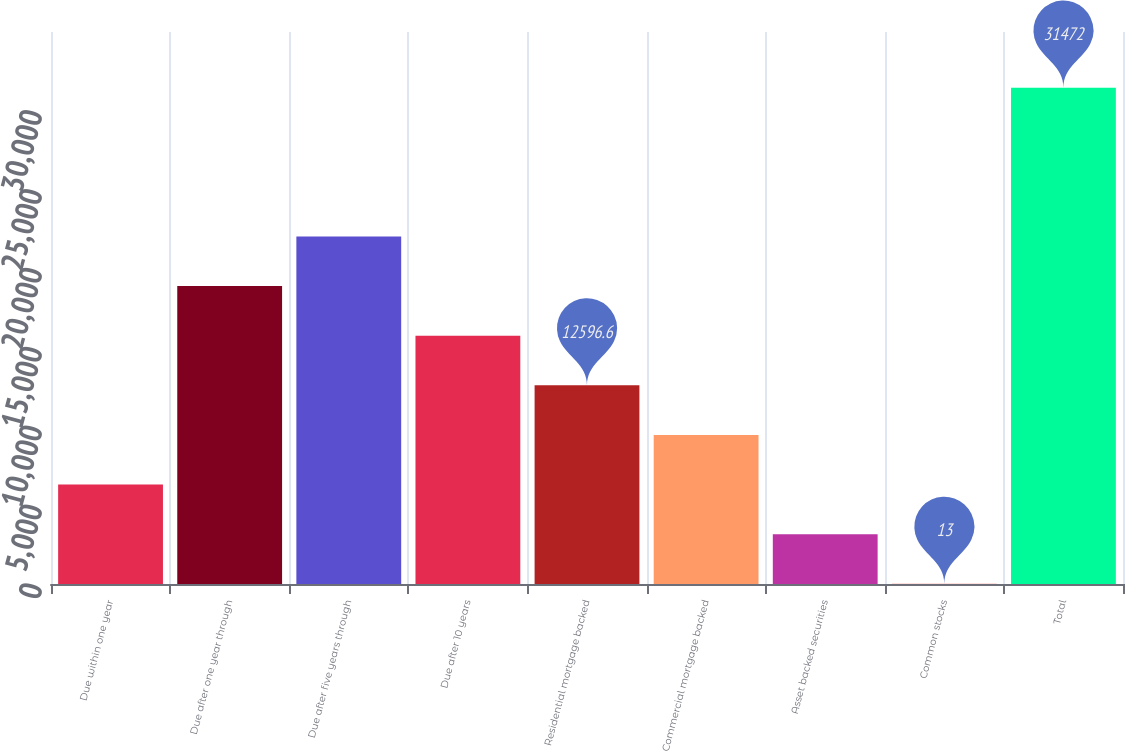Convert chart. <chart><loc_0><loc_0><loc_500><loc_500><bar_chart><fcel>Due within one year<fcel>Due after one year through<fcel>Due after five years through<fcel>Due after 10 years<fcel>Residential mortgage backed<fcel>Commercial mortgage backed<fcel>Asset backed securities<fcel>Common stocks<fcel>Total<nl><fcel>6304.8<fcel>18888.4<fcel>22034.3<fcel>15742.5<fcel>12596.6<fcel>9450.7<fcel>3158.9<fcel>13<fcel>31472<nl></chart> 